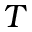<formula> <loc_0><loc_0><loc_500><loc_500>T</formula> 